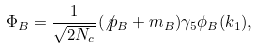<formula> <loc_0><loc_0><loc_500><loc_500>\Phi _ { B } = \frac { 1 } { \sqrt { 2 N _ { c } } } ( \not p _ { B } + m _ { B } ) \gamma _ { 5 } \phi _ { B } ( { k _ { 1 } } ) ,</formula> 